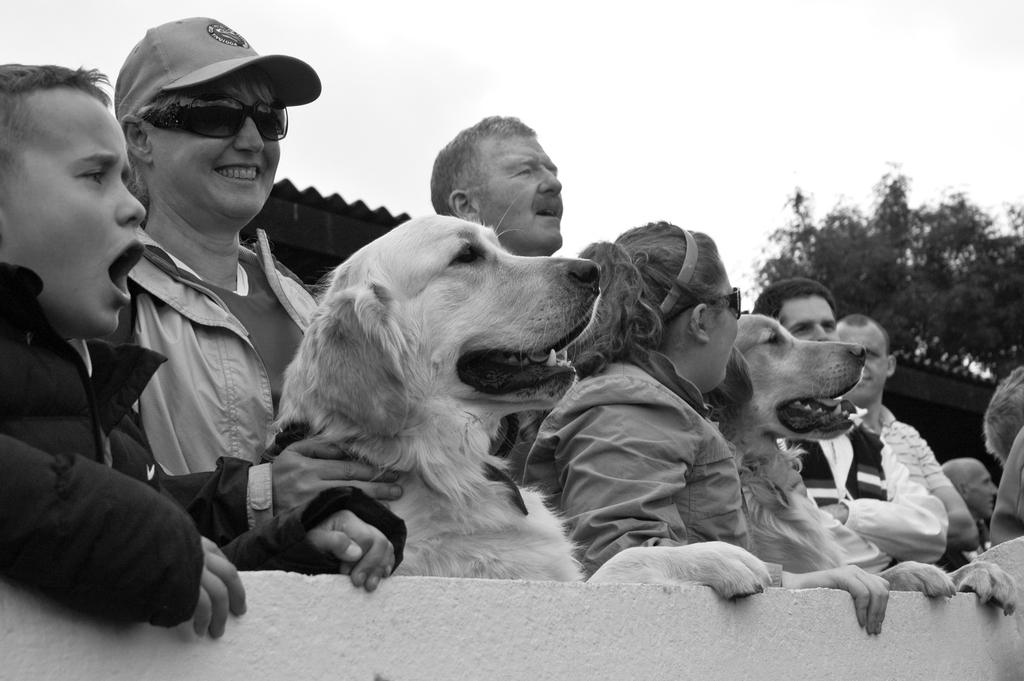What can be seen in the foreground of the image? There is a group of people standing on the road and two dogs in the foreground. What is visible in the background of the image? There are trees, houses, and the sky visible in the background. Can you describe the time of day when the image was taken? The image appears to be taken during the day. What sound can be heard coming from the dogs in the image? There is no sound present in the image, so it is not possible to determine what the dogs might be heard saying or doing. 